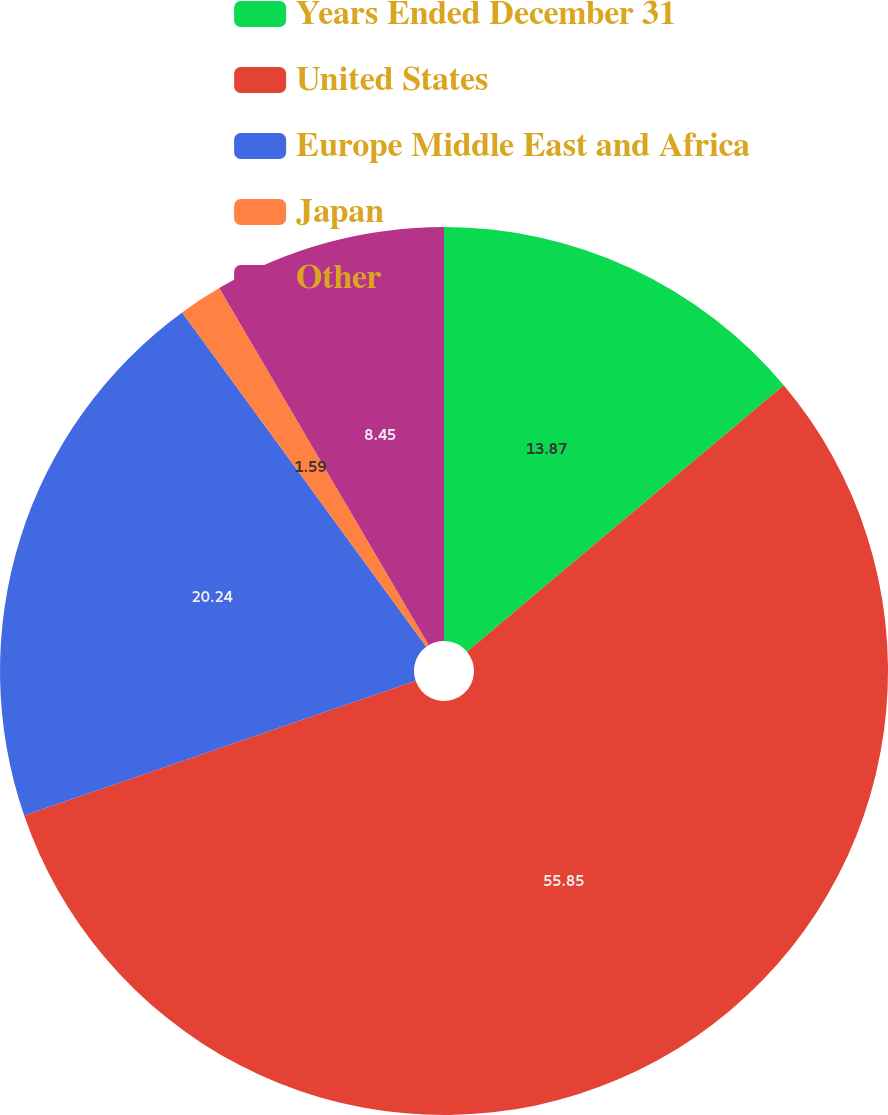Convert chart. <chart><loc_0><loc_0><loc_500><loc_500><pie_chart><fcel>Years Ended December 31<fcel>United States<fcel>Europe Middle East and Africa<fcel>Japan<fcel>Other<nl><fcel>13.87%<fcel>55.86%<fcel>20.24%<fcel>1.59%<fcel>8.45%<nl></chart> 